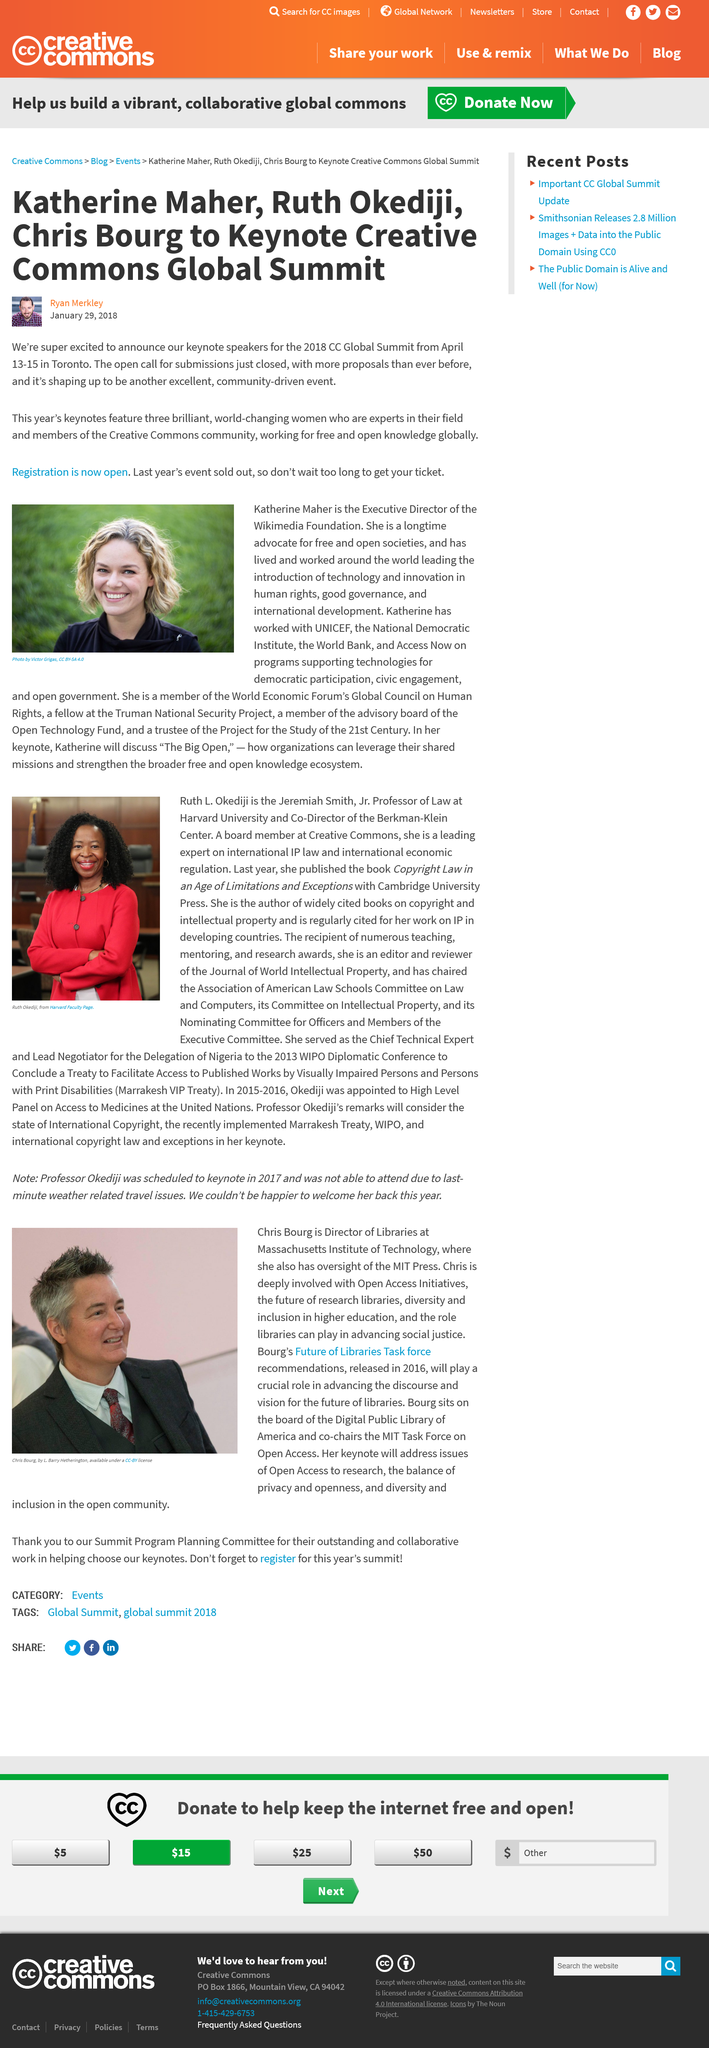List a handful of essential elements in this visual. The CC Global Summit of 2017 was sold out. The Creative Commons community strives to promote free and open access to knowledge globally, without restriction or cost. The three women who will be speaking at the CC Global Summit are Katherine Maher, Ruth Okediji, and Chris Bourg. 